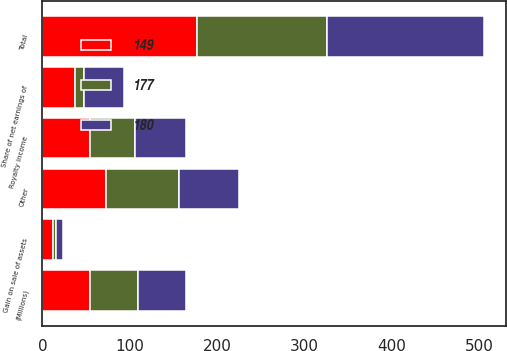Convert chart to OTSL. <chart><loc_0><loc_0><loc_500><loc_500><stacked_bar_chart><ecel><fcel>(Millions)<fcel>Royalty income<fcel>Share of net earnings of<fcel>Gain on sale of assets<fcel>Other<fcel>Total<nl><fcel>177<fcel>55<fcel>51<fcel>11<fcel>4<fcel>83<fcel>149<nl><fcel>149<fcel>55<fcel>55<fcel>37<fcel>12<fcel>73<fcel>177<nl><fcel>180<fcel>55<fcel>58<fcel>45<fcel>8<fcel>69<fcel>180<nl></chart> 